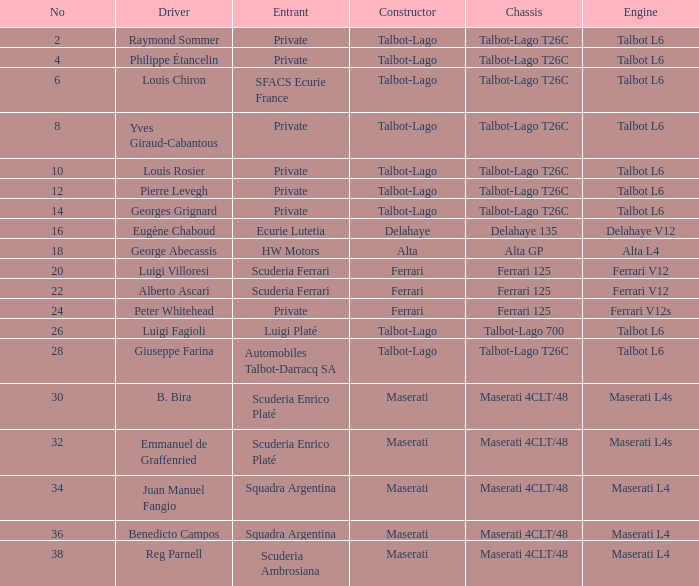Name the constructor for number 10 Talbot-Lago. 